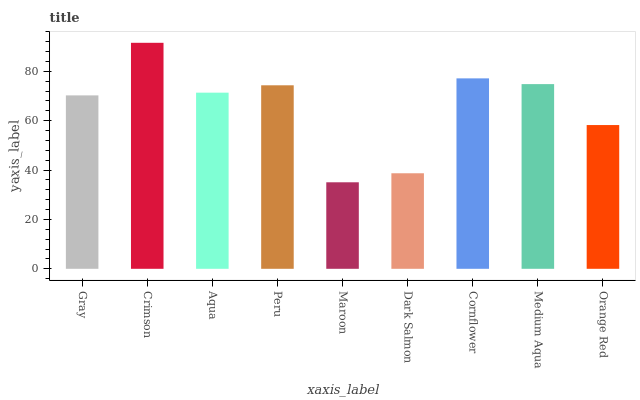Is Maroon the minimum?
Answer yes or no. Yes. Is Crimson the maximum?
Answer yes or no. Yes. Is Aqua the minimum?
Answer yes or no. No. Is Aqua the maximum?
Answer yes or no. No. Is Crimson greater than Aqua?
Answer yes or no. Yes. Is Aqua less than Crimson?
Answer yes or no. Yes. Is Aqua greater than Crimson?
Answer yes or no. No. Is Crimson less than Aqua?
Answer yes or no. No. Is Aqua the high median?
Answer yes or no. Yes. Is Aqua the low median?
Answer yes or no. Yes. Is Cornflower the high median?
Answer yes or no. No. Is Medium Aqua the low median?
Answer yes or no. No. 